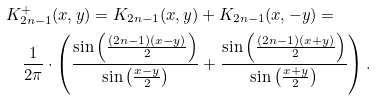<formula> <loc_0><loc_0><loc_500><loc_500>& K ^ { + } _ { 2 n - 1 } ( x , y ) = K _ { 2 n - 1 } ( x , y ) + K _ { 2 n - 1 } ( x , - y ) = \\ & \quad \frac { 1 } { 2 \pi } \cdot \left ( \frac { \sin \left ( \frac { ( 2 n - 1 ) ( x - y ) } { 2 } \right ) } { \sin \left ( \frac { x - y } { 2 } \right ) } + \frac { \sin \left ( \frac { ( 2 n - 1 ) ( x + y ) } { 2 } \right ) } { \sin \left ( \frac { x + y } { 2 } \right ) } \right ) .</formula> 